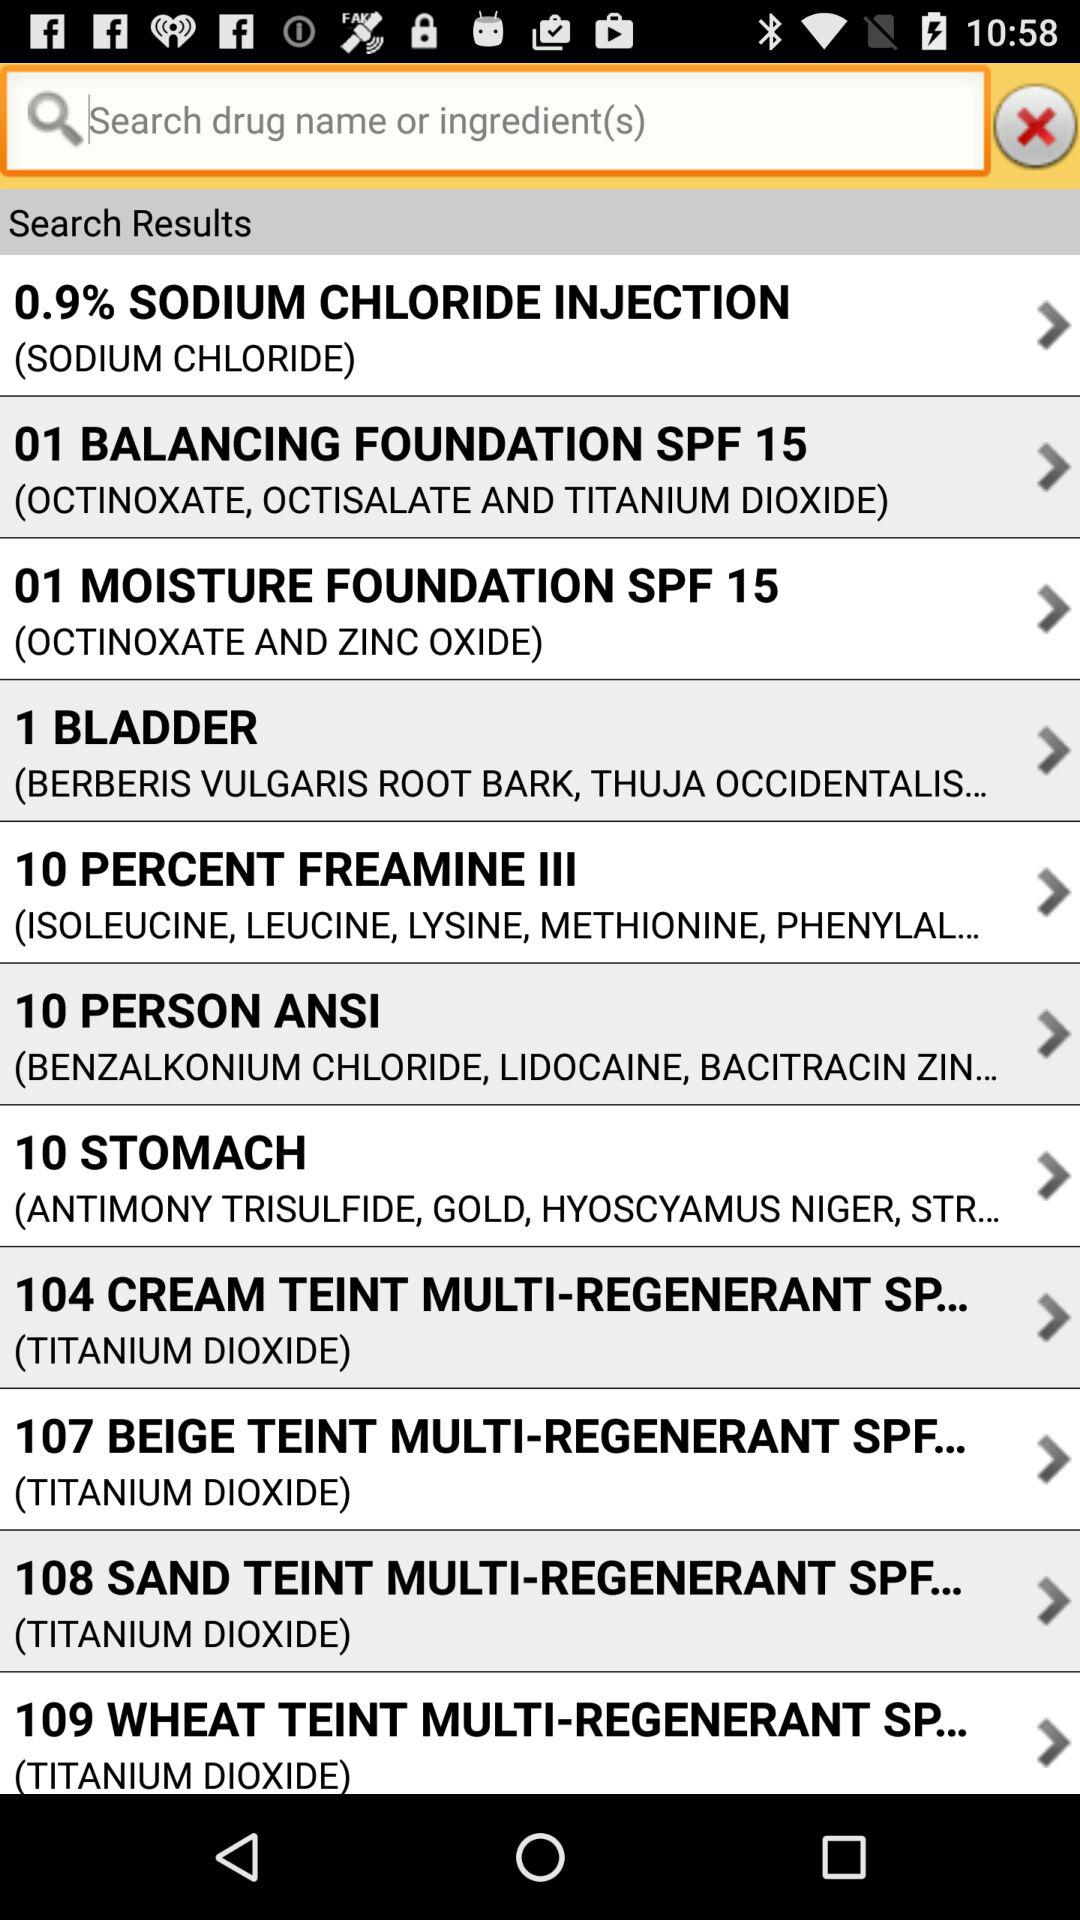What are the ingredients in "10 PERSON ANSI"? The ingredients in "10 PERSON ANSI" are benzalkonium chloride, lidocaine, and "BACITRACIN ZIN...". 